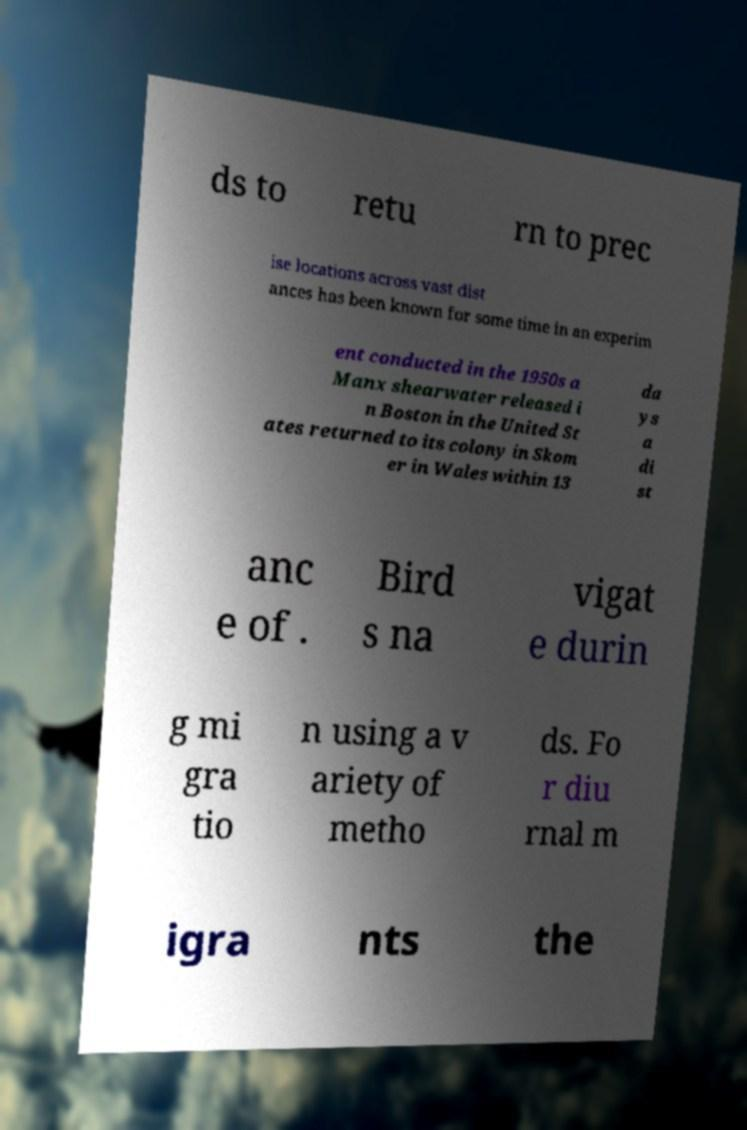There's text embedded in this image that I need extracted. Can you transcribe it verbatim? ds to retu rn to prec ise locations across vast dist ances has been known for some time in an experim ent conducted in the 1950s a Manx shearwater released i n Boston in the United St ates returned to its colony in Skom er in Wales within 13 da ys a di st anc e of . Bird s na vigat e durin g mi gra tio n using a v ariety of metho ds. Fo r diu rnal m igra nts the 